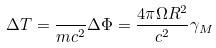Convert formula to latex. <formula><loc_0><loc_0><loc_500><loc_500>\Delta T = \frac { } { m c ^ { 2 } } \Delta \Phi = \frac { 4 \pi \Omega R ^ { 2 } } { c ^ { 2 } } \gamma _ { M }</formula> 